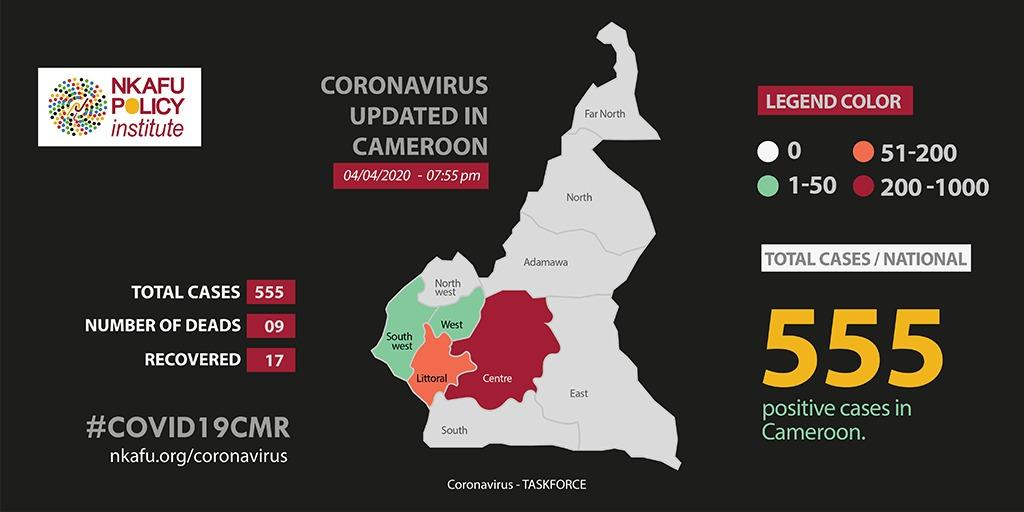Indicate a few pertinent items in this graphic. As of April 4, 2020, the total number of positive cases of Covid-19 reported in Cameroon is 555. As of April 4th, 2020, the range of COVID-19 cases in the Adamawa region of Cameroon is unknown. As of April 4th, 2020, the reported range of COVID-19 cases in the south-west region of Cameroon was between 1 and 50. As of April 4, 2020, the number of reported Covid-19 deaths in Cameroon was 0. The range of COVID-19 cases in the Littoral region of Cameroon as of April 4, 2020, was between 51 and 200. 